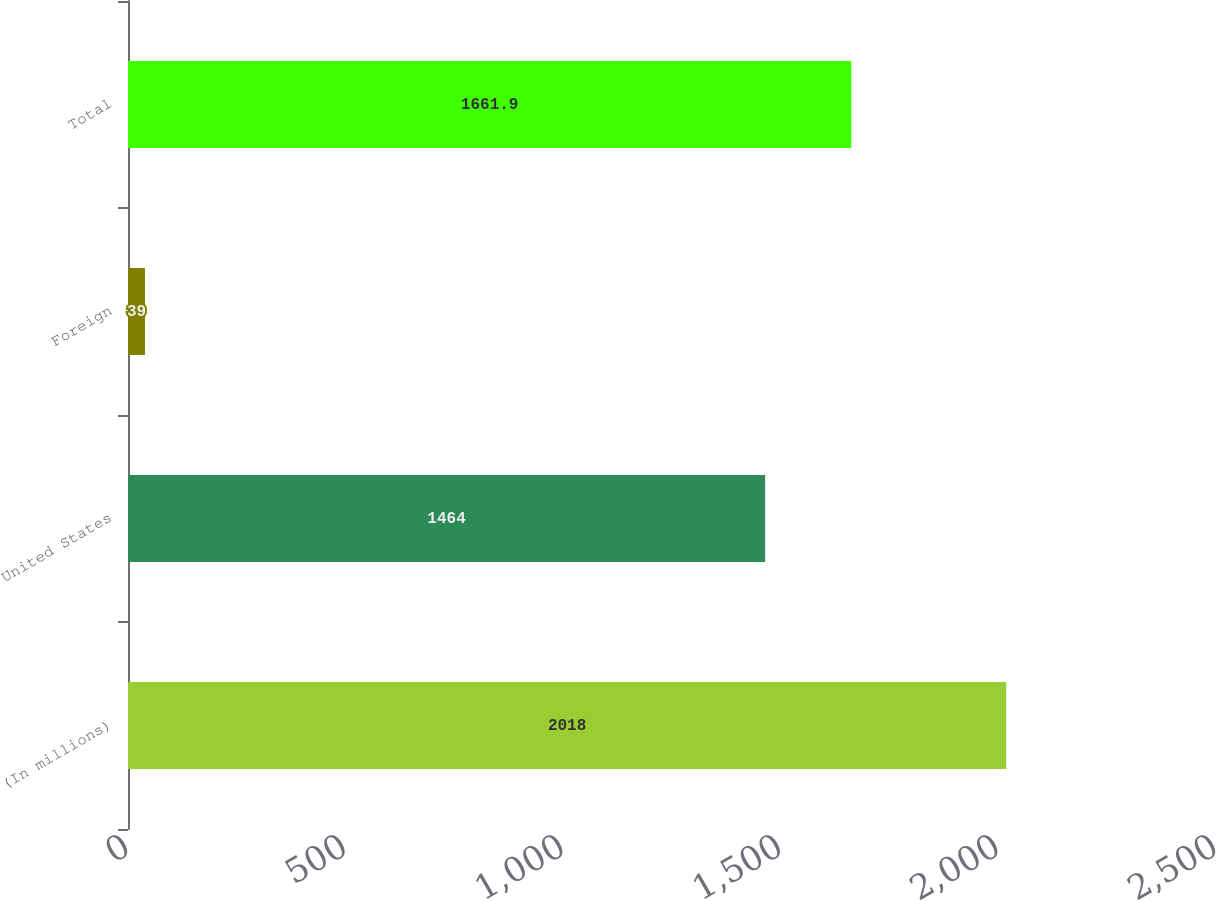Convert chart. <chart><loc_0><loc_0><loc_500><loc_500><bar_chart><fcel>(In millions)<fcel>United States<fcel>Foreign<fcel>Total<nl><fcel>2018<fcel>1464<fcel>39<fcel>1661.9<nl></chart> 